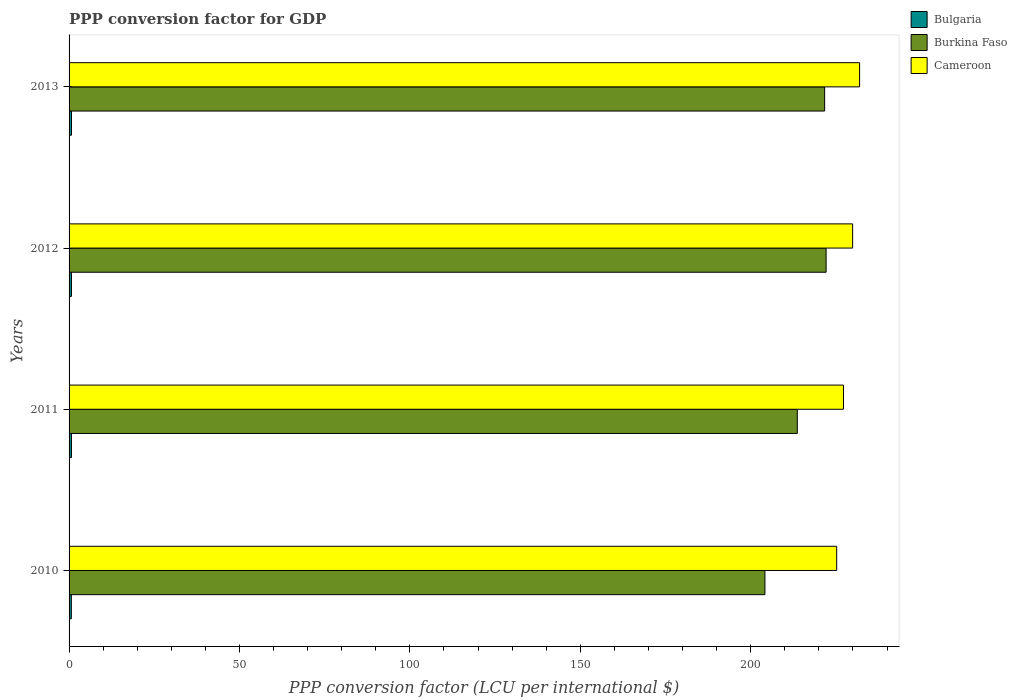How many bars are there on the 1st tick from the top?
Provide a succinct answer. 3. How many bars are there on the 4th tick from the bottom?
Your response must be concise. 3. What is the label of the 2nd group of bars from the top?
Your answer should be compact. 2012. What is the PPP conversion factor for GDP in Burkina Faso in 2013?
Offer a very short reply. 221.68. Across all years, what is the maximum PPP conversion factor for GDP in Bulgaria?
Your answer should be compact. 0.7. Across all years, what is the minimum PPP conversion factor for GDP in Bulgaria?
Ensure brevity in your answer.  0.66. In which year was the PPP conversion factor for GDP in Burkina Faso maximum?
Your answer should be very brief. 2012. What is the total PPP conversion factor for GDP in Cameroon in the graph?
Provide a succinct answer. 914.27. What is the difference between the PPP conversion factor for GDP in Burkina Faso in 2011 and that in 2013?
Your response must be concise. -8.02. What is the difference between the PPP conversion factor for GDP in Burkina Faso in 2013 and the PPP conversion factor for GDP in Cameroon in 2012?
Your response must be concise. -8.22. What is the average PPP conversion factor for GDP in Burkina Faso per year?
Provide a short and direct response. 215.4. In the year 2011, what is the difference between the PPP conversion factor for GDP in Cameroon and PPP conversion factor for GDP in Bulgaria?
Ensure brevity in your answer.  226.51. In how many years, is the PPP conversion factor for GDP in Burkina Faso greater than 20 LCU?
Make the answer very short. 4. What is the ratio of the PPP conversion factor for GDP in Cameroon in 2011 to that in 2013?
Your answer should be very brief. 0.98. Is the PPP conversion factor for GDP in Burkina Faso in 2010 less than that in 2012?
Keep it short and to the point. Yes. Is the difference between the PPP conversion factor for GDP in Cameroon in 2011 and 2012 greater than the difference between the PPP conversion factor for GDP in Bulgaria in 2011 and 2012?
Keep it short and to the point. No. What is the difference between the highest and the second highest PPP conversion factor for GDP in Bulgaria?
Provide a short and direct response. 0. What is the difference between the highest and the lowest PPP conversion factor for GDP in Burkina Faso?
Your response must be concise. 17.95. Is the sum of the PPP conversion factor for GDP in Cameroon in 2010 and 2012 greater than the maximum PPP conversion factor for GDP in Burkina Faso across all years?
Offer a terse response. Yes. What does the 1st bar from the top in 2013 represents?
Offer a terse response. Cameroon. What does the 2nd bar from the bottom in 2011 represents?
Provide a succinct answer. Burkina Faso. Is it the case that in every year, the sum of the PPP conversion factor for GDP in Cameroon and PPP conversion factor for GDP in Bulgaria is greater than the PPP conversion factor for GDP in Burkina Faso?
Offer a terse response. Yes. Where does the legend appear in the graph?
Ensure brevity in your answer.  Top right. How many legend labels are there?
Your answer should be compact. 3. How are the legend labels stacked?
Make the answer very short. Vertical. What is the title of the graph?
Offer a terse response. PPP conversion factor for GDP. What is the label or title of the X-axis?
Offer a terse response. PPP conversion factor (LCU per international $). What is the label or title of the Y-axis?
Make the answer very short. Years. What is the PPP conversion factor (LCU per international $) of Bulgaria in 2010?
Your answer should be very brief. 0.66. What is the PPP conversion factor (LCU per international $) in Burkina Faso in 2010?
Your answer should be very brief. 204.16. What is the PPP conversion factor (LCU per international $) in Cameroon in 2010?
Provide a short and direct response. 225.22. What is the PPP conversion factor (LCU per international $) of Bulgaria in 2011?
Your answer should be compact. 0.7. What is the PPP conversion factor (LCU per international $) of Burkina Faso in 2011?
Your answer should be compact. 213.66. What is the PPP conversion factor (LCU per international $) in Cameroon in 2011?
Offer a very short reply. 227.21. What is the PPP conversion factor (LCU per international $) in Bulgaria in 2012?
Keep it short and to the point. 0.7. What is the PPP conversion factor (LCU per international $) of Burkina Faso in 2012?
Your answer should be compact. 222.12. What is the PPP conversion factor (LCU per international $) in Cameroon in 2012?
Your response must be concise. 229.9. What is the PPP conversion factor (LCU per international $) of Bulgaria in 2013?
Your answer should be compact. 0.7. What is the PPP conversion factor (LCU per international $) of Burkina Faso in 2013?
Keep it short and to the point. 221.68. What is the PPP conversion factor (LCU per international $) of Cameroon in 2013?
Give a very brief answer. 231.94. Across all years, what is the maximum PPP conversion factor (LCU per international $) in Bulgaria?
Provide a succinct answer. 0.7. Across all years, what is the maximum PPP conversion factor (LCU per international $) of Burkina Faso?
Keep it short and to the point. 222.12. Across all years, what is the maximum PPP conversion factor (LCU per international $) in Cameroon?
Make the answer very short. 231.94. Across all years, what is the minimum PPP conversion factor (LCU per international $) of Bulgaria?
Provide a short and direct response. 0.66. Across all years, what is the minimum PPP conversion factor (LCU per international $) in Burkina Faso?
Provide a succinct answer. 204.16. Across all years, what is the minimum PPP conversion factor (LCU per international $) of Cameroon?
Your response must be concise. 225.22. What is the total PPP conversion factor (LCU per international $) in Bulgaria in the graph?
Make the answer very short. 2.76. What is the total PPP conversion factor (LCU per international $) in Burkina Faso in the graph?
Your answer should be very brief. 861.62. What is the total PPP conversion factor (LCU per international $) of Cameroon in the graph?
Offer a very short reply. 914.27. What is the difference between the PPP conversion factor (LCU per international $) in Bulgaria in 2010 and that in 2011?
Your response must be concise. -0.04. What is the difference between the PPP conversion factor (LCU per international $) of Burkina Faso in 2010 and that in 2011?
Your response must be concise. -9.49. What is the difference between the PPP conversion factor (LCU per international $) in Cameroon in 2010 and that in 2011?
Give a very brief answer. -1.99. What is the difference between the PPP conversion factor (LCU per international $) of Bulgaria in 2010 and that in 2012?
Provide a short and direct response. -0.04. What is the difference between the PPP conversion factor (LCU per international $) in Burkina Faso in 2010 and that in 2012?
Offer a terse response. -17.95. What is the difference between the PPP conversion factor (LCU per international $) in Cameroon in 2010 and that in 2012?
Provide a short and direct response. -4.68. What is the difference between the PPP conversion factor (LCU per international $) in Bulgaria in 2010 and that in 2013?
Provide a short and direct response. -0.04. What is the difference between the PPP conversion factor (LCU per international $) of Burkina Faso in 2010 and that in 2013?
Ensure brevity in your answer.  -17.52. What is the difference between the PPP conversion factor (LCU per international $) of Cameroon in 2010 and that in 2013?
Offer a terse response. -6.72. What is the difference between the PPP conversion factor (LCU per international $) of Bulgaria in 2011 and that in 2012?
Your answer should be very brief. -0. What is the difference between the PPP conversion factor (LCU per international $) of Burkina Faso in 2011 and that in 2012?
Your response must be concise. -8.46. What is the difference between the PPP conversion factor (LCU per international $) in Cameroon in 2011 and that in 2012?
Provide a succinct answer. -2.68. What is the difference between the PPP conversion factor (LCU per international $) of Bulgaria in 2011 and that in 2013?
Ensure brevity in your answer.  -0. What is the difference between the PPP conversion factor (LCU per international $) in Burkina Faso in 2011 and that in 2013?
Offer a very short reply. -8.02. What is the difference between the PPP conversion factor (LCU per international $) of Cameroon in 2011 and that in 2013?
Provide a succinct answer. -4.73. What is the difference between the PPP conversion factor (LCU per international $) of Bulgaria in 2012 and that in 2013?
Provide a succinct answer. -0. What is the difference between the PPP conversion factor (LCU per international $) in Burkina Faso in 2012 and that in 2013?
Give a very brief answer. 0.44. What is the difference between the PPP conversion factor (LCU per international $) of Cameroon in 2012 and that in 2013?
Provide a succinct answer. -2.04. What is the difference between the PPP conversion factor (LCU per international $) in Bulgaria in 2010 and the PPP conversion factor (LCU per international $) in Burkina Faso in 2011?
Provide a succinct answer. -213. What is the difference between the PPP conversion factor (LCU per international $) in Bulgaria in 2010 and the PPP conversion factor (LCU per international $) in Cameroon in 2011?
Your answer should be very brief. -226.55. What is the difference between the PPP conversion factor (LCU per international $) of Burkina Faso in 2010 and the PPP conversion factor (LCU per international $) of Cameroon in 2011?
Provide a succinct answer. -23.05. What is the difference between the PPP conversion factor (LCU per international $) of Bulgaria in 2010 and the PPP conversion factor (LCU per international $) of Burkina Faso in 2012?
Your answer should be compact. -221.45. What is the difference between the PPP conversion factor (LCU per international $) of Bulgaria in 2010 and the PPP conversion factor (LCU per international $) of Cameroon in 2012?
Offer a very short reply. -229.23. What is the difference between the PPP conversion factor (LCU per international $) in Burkina Faso in 2010 and the PPP conversion factor (LCU per international $) in Cameroon in 2012?
Offer a terse response. -25.73. What is the difference between the PPP conversion factor (LCU per international $) in Bulgaria in 2010 and the PPP conversion factor (LCU per international $) in Burkina Faso in 2013?
Keep it short and to the point. -221.02. What is the difference between the PPP conversion factor (LCU per international $) in Bulgaria in 2010 and the PPP conversion factor (LCU per international $) in Cameroon in 2013?
Provide a short and direct response. -231.28. What is the difference between the PPP conversion factor (LCU per international $) of Burkina Faso in 2010 and the PPP conversion factor (LCU per international $) of Cameroon in 2013?
Provide a succinct answer. -27.77. What is the difference between the PPP conversion factor (LCU per international $) of Bulgaria in 2011 and the PPP conversion factor (LCU per international $) of Burkina Faso in 2012?
Your answer should be very brief. -221.42. What is the difference between the PPP conversion factor (LCU per international $) in Bulgaria in 2011 and the PPP conversion factor (LCU per international $) in Cameroon in 2012?
Offer a very short reply. -229.2. What is the difference between the PPP conversion factor (LCU per international $) in Burkina Faso in 2011 and the PPP conversion factor (LCU per international $) in Cameroon in 2012?
Offer a terse response. -16.24. What is the difference between the PPP conversion factor (LCU per international $) in Bulgaria in 2011 and the PPP conversion factor (LCU per international $) in Burkina Faso in 2013?
Offer a very short reply. -220.98. What is the difference between the PPP conversion factor (LCU per international $) of Bulgaria in 2011 and the PPP conversion factor (LCU per international $) of Cameroon in 2013?
Your answer should be compact. -231.24. What is the difference between the PPP conversion factor (LCU per international $) in Burkina Faso in 2011 and the PPP conversion factor (LCU per international $) in Cameroon in 2013?
Offer a terse response. -18.28. What is the difference between the PPP conversion factor (LCU per international $) of Bulgaria in 2012 and the PPP conversion factor (LCU per international $) of Burkina Faso in 2013?
Give a very brief answer. -220.98. What is the difference between the PPP conversion factor (LCU per international $) of Bulgaria in 2012 and the PPP conversion factor (LCU per international $) of Cameroon in 2013?
Give a very brief answer. -231.24. What is the difference between the PPP conversion factor (LCU per international $) of Burkina Faso in 2012 and the PPP conversion factor (LCU per international $) of Cameroon in 2013?
Your answer should be very brief. -9.82. What is the average PPP conversion factor (LCU per international $) of Bulgaria per year?
Ensure brevity in your answer.  0.69. What is the average PPP conversion factor (LCU per international $) of Burkina Faso per year?
Your response must be concise. 215.4. What is the average PPP conversion factor (LCU per international $) in Cameroon per year?
Ensure brevity in your answer.  228.57. In the year 2010, what is the difference between the PPP conversion factor (LCU per international $) in Bulgaria and PPP conversion factor (LCU per international $) in Burkina Faso?
Make the answer very short. -203.5. In the year 2010, what is the difference between the PPP conversion factor (LCU per international $) in Bulgaria and PPP conversion factor (LCU per international $) in Cameroon?
Your response must be concise. -224.56. In the year 2010, what is the difference between the PPP conversion factor (LCU per international $) in Burkina Faso and PPP conversion factor (LCU per international $) in Cameroon?
Your answer should be compact. -21.06. In the year 2011, what is the difference between the PPP conversion factor (LCU per international $) of Bulgaria and PPP conversion factor (LCU per international $) of Burkina Faso?
Your response must be concise. -212.96. In the year 2011, what is the difference between the PPP conversion factor (LCU per international $) of Bulgaria and PPP conversion factor (LCU per international $) of Cameroon?
Provide a short and direct response. -226.51. In the year 2011, what is the difference between the PPP conversion factor (LCU per international $) of Burkina Faso and PPP conversion factor (LCU per international $) of Cameroon?
Keep it short and to the point. -13.55. In the year 2012, what is the difference between the PPP conversion factor (LCU per international $) of Bulgaria and PPP conversion factor (LCU per international $) of Burkina Faso?
Keep it short and to the point. -221.42. In the year 2012, what is the difference between the PPP conversion factor (LCU per international $) in Bulgaria and PPP conversion factor (LCU per international $) in Cameroon?
Give a very brief answer. -229.2. In the year 2012, what is the difference between the PPP conversion factor (LCU per international $) of Burkina Faso and PPP conversion factor (LCU per international $) of Cameroon?
Keep it short and to the point. -7.78. In the year 2013, what is the difference between the PPP conversion factor (LCU per international $) in Bulgaria and PPP conversion factor (LCU per international $) in Burkina Faso?
Give a very brief answer. -220.98. In the year 2013, what is the difference between the PPP conversion factor (LCU per international $) in Bulgaria and PPP conversion factor (LCU per international $) in Cameroon?
Make the answer very short. -231.24. In the year 2013, what is the difference between the PPP conversion factor (LCU per international $) of Burkina Faso and PPP conversion factor (LCU per international $) of Cameroon?
Your response must be concise. -10.26. What is the ratio of the PPP conversion factor (LCU per international $) of Bulgaria in 2010 to that in 2011?
Your response must be concise. 0.95. What is the ratio of the PPP conversion factor (LCU per international $) of Burkina Faso in 2010 to that in 2011?
Ensure brevity in your answer.  0.96. What is the ratio of the PPP conversion factor (LCU per international $) of Bulgaria in 2010 to that in 2012?
Offer a terse response. 0.95. What is the ratio of the PPP conversion factor (LCU per international $) of Burkina Faso in 2010 to that in 2012?
Give a very brief answer. 0.92. What is the ratio of the PPP conversion factor (LCU per international $) of Cameroon in 2010 to that in 2012?
Provide a short and direct response. 0.98. What is the ratio of the PPP conversion factor (LCU per international $) in Bulgaria in 2010 to that in 2013?
Offer a very short reply. 0.94. What is the ratio of the PPP conversion factor (LCU per international $) of Burkina Faso in 2010 to that in 2013?
Keep it short and to the point. 0.92. What is the ratio of the PPP conversion factor (LCU per international $) in Bulgaria in 2011 to that in 2012?
Your response must be concise. 1. What is the ratio of the PPP conversion factor (LCU per international $) of Burkina Faso in 2011 to that in 2012?
Keep it short and to the point. 0.96. What is the ratio of the PPP conversion factor (LCU per international $) in Cameroon in 2011 to that in 2012?
Your answer should be very brief. 0.99. What is the ratio of the PPP conversion factor (LCU per international $) of Burkina Faso in 2011 to that in 2013?
Your answer should be compact. 0.96. What is the ratio of the PPP conversion factor (LCU per international $) of Cameroon in 2011 to that in 2013?
Provide a succinct answer. 0.98. What is the ratio of the PPP conversion factor (LCU per international $) in Bulgaria in 2012 to that in 2013?
Make the answer very short. 1. What is the difference between the highest and the second highest PPP conversion factor (LCU per international $) in Bulgaria?
Your answer should be very brief. 0. What is the difference between the highest and the second highest PPP conversion factor (LCU per international $) of Burkina Faso?
Your answer should be compact. 0.44. What is the difference between the highest and the second highest PPP conversion factor (LCU per international $) of Cameroon?
Ensure brevity in your answer.  2.04. What is the difference between the highest and the lowest PPP conversion factor (LCU per international $) in Bulgaria?
Give a very brief answer. 0.04. What is the difference between the highest and the lowest PPP conversion factor (LCU per international $) in Burkina Faso?
Offer a terse response. 17.95. What is the difference between the highest and the lowest PPP conversion factor (LCU per international $) of Cameroon?
Offer a terse response. 6.72. 